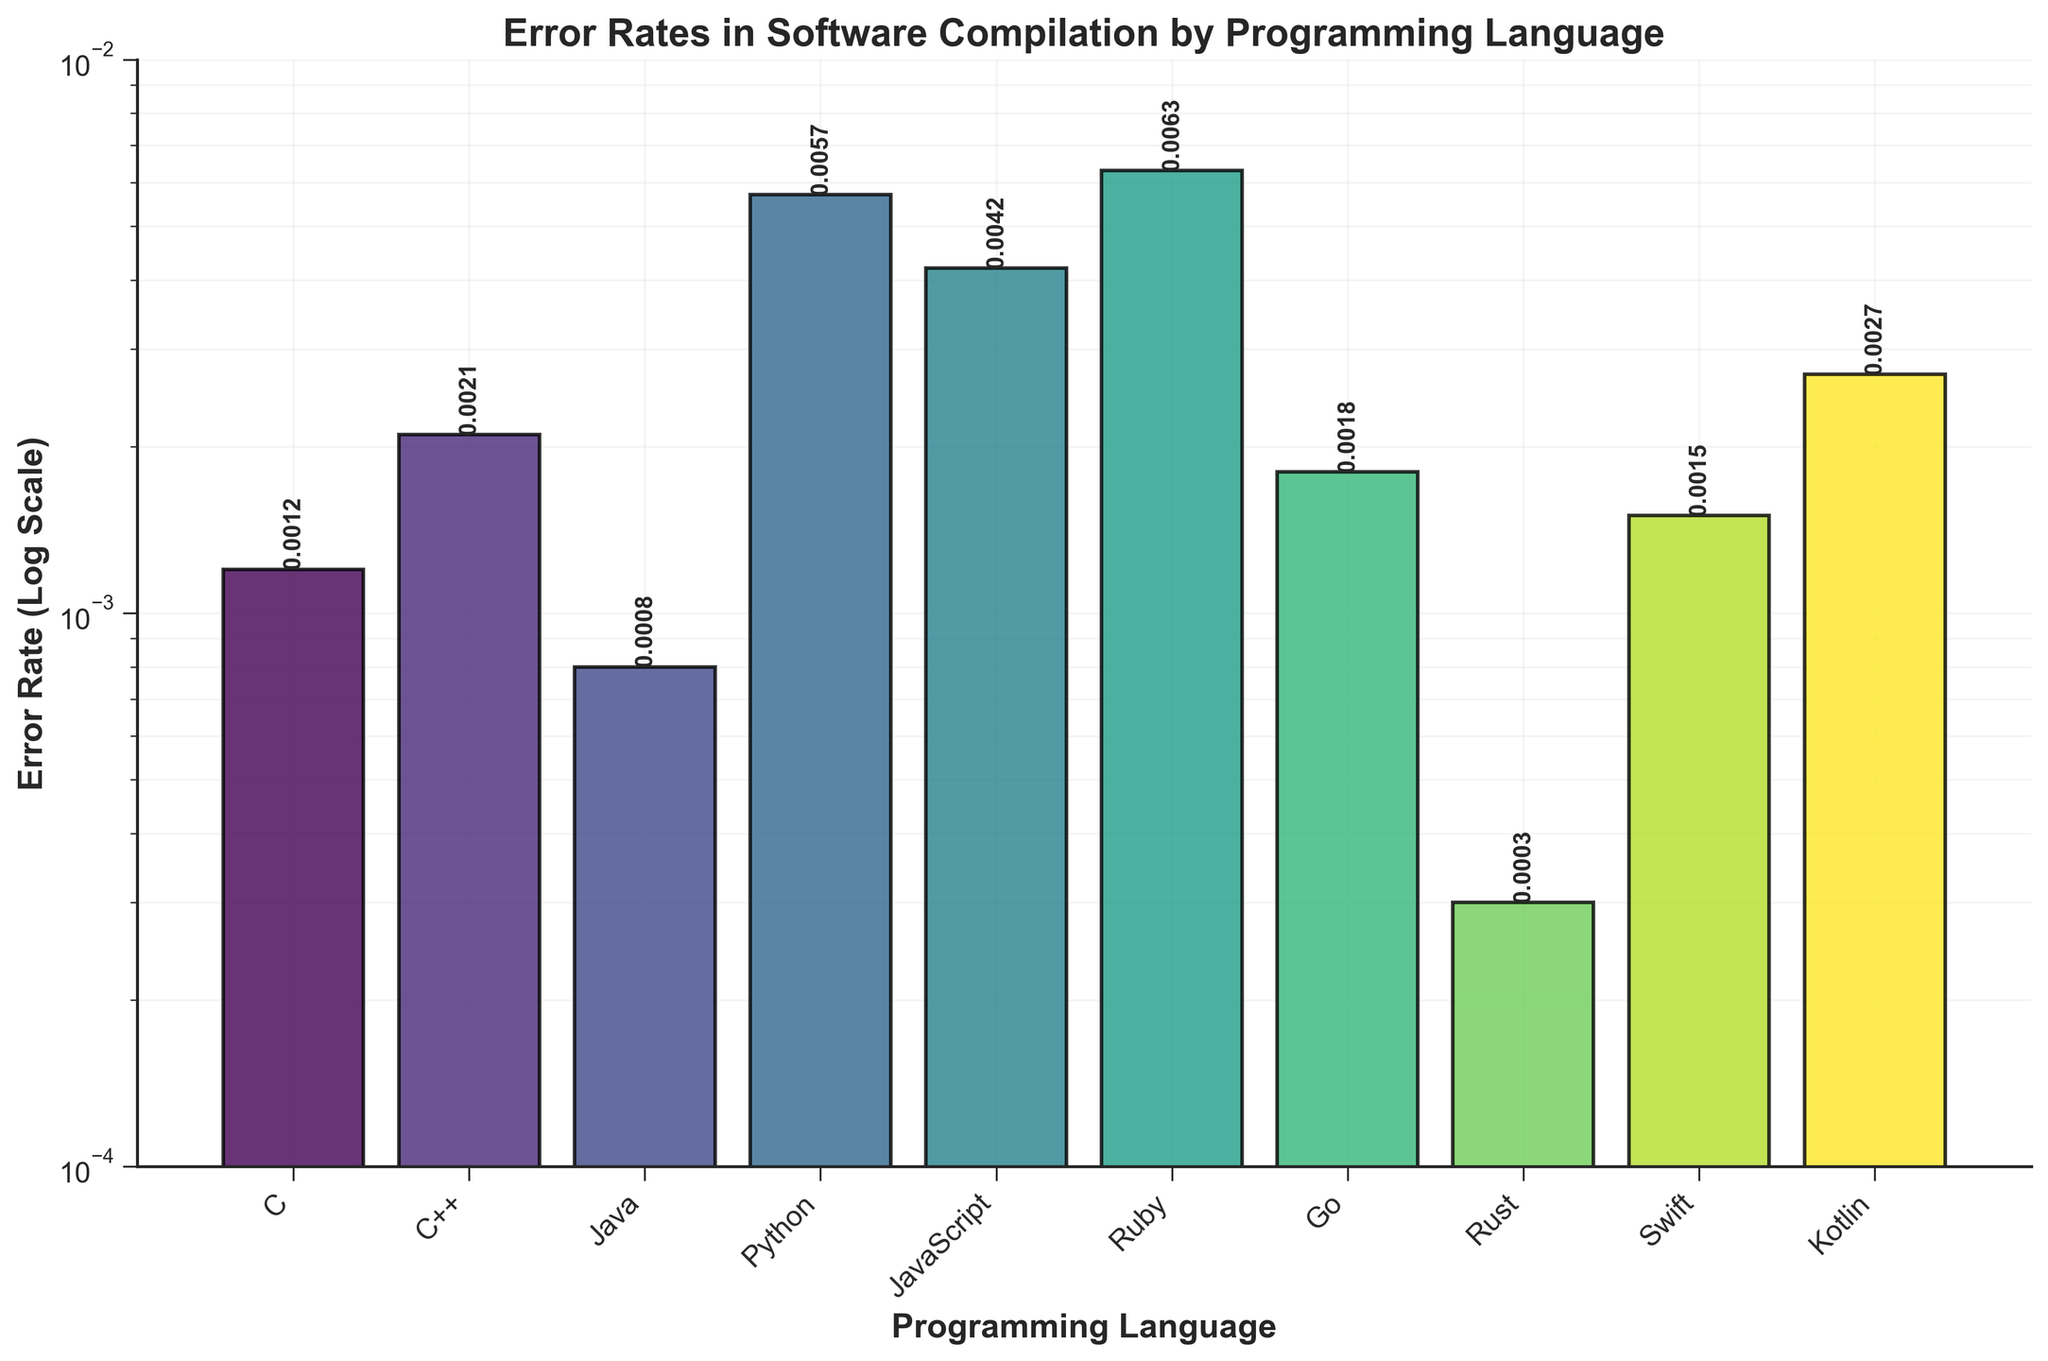What is the title of the figure? The title is displayed at the top of the figure, which summarizes what the figure is about. It reads "Error Rates in Software Compilation by Programming Language".
Answer: Error Rates in Software Compilation by Programming Language Which programming language has the lowest error rate? By examining the height of the bars, the shortest bar corresponds to Rust. Looking at the text label above the bar shows Rust's error rate as 0.0003, which is the lowest.
Answer: Rust What is the error rate for Python? To find the error rate for Python, look for the bar labeled "Python". The text above the bar indicates the exact error rate, which is 0.0057.
Answer: 0.0057 Which programming languages have error rates greater than 0.002? Scan each bar and refer to the text labels above. The languages meeting this criterion are C++, Python, JavaScript, Ruby, and Kotlin.
Answer: C++, Python, JavaScript, Ruby, Kotlin How does Java’s error rate compare to C’s error rate? Identify the bars for Java and C and compare their heights. Java's bar is slightly shorter than C's. Looking at the text labels, Java's error rate is 0.0008 and C's is 0.0012; hence, Java's error rate is lower.
Answer: Java’s error rate is lower than C’s What is the range of error rates in the figure? The range is found by subtracting the smallest value from the largest value among the error rates. The smallest is 0.0003 (Rust), and the largest is 0.0063 (Ruby). Therefore, the range is 0.0063 - 0.0003 = 0.006.
Answer: 0.006 What is the error rate for Swift and how does it compare to Kotlin's? Locate the bars for Swift and Kotlin and read their error rates from the labels. Swift's error rate is 0.0015, and Kotlin's error rate is 0.0027. Comparing these, Swift's error rate is lower than Kotlin's.
Answer: Swift’s error rate is lower than Kotlin’s What's the average error rate of the programming languages? Sum all the error rates and divide by the number of languages. Total error rate is 0.0012 + 0.0021 + 0.0008 + 0.0057 + 0.0042 + 0.0063 + 0.0018 + 0.0003 + 0.0015 + 0.0027 = 0.0266. Divide by 10: 0.0266 / 10 = 0.00266.
Answer: 0.00266 By what factor does Ruby’s error rate exceed Rust’s error rate? Ruby's error rate is 0.0063 and Rust's is 0.0003. The factor by which Ruby's exceeds Rust's is 0.0063 / 0.0003 = 21.
Answer: 21 What is the median error rate of the programming languages? Arrange the error rates in ascending order: 0.0003, 0.0008, 0.0012, 0.0015, 0.0018, 0.0021, 0.0027, 0.0042, 0.0057, 0.0063. With 10 values, the median is the average of the 5th and 6th values: (0.0018 + 0.0021) / 2 = 0.00195.
Answer: 0.00195 